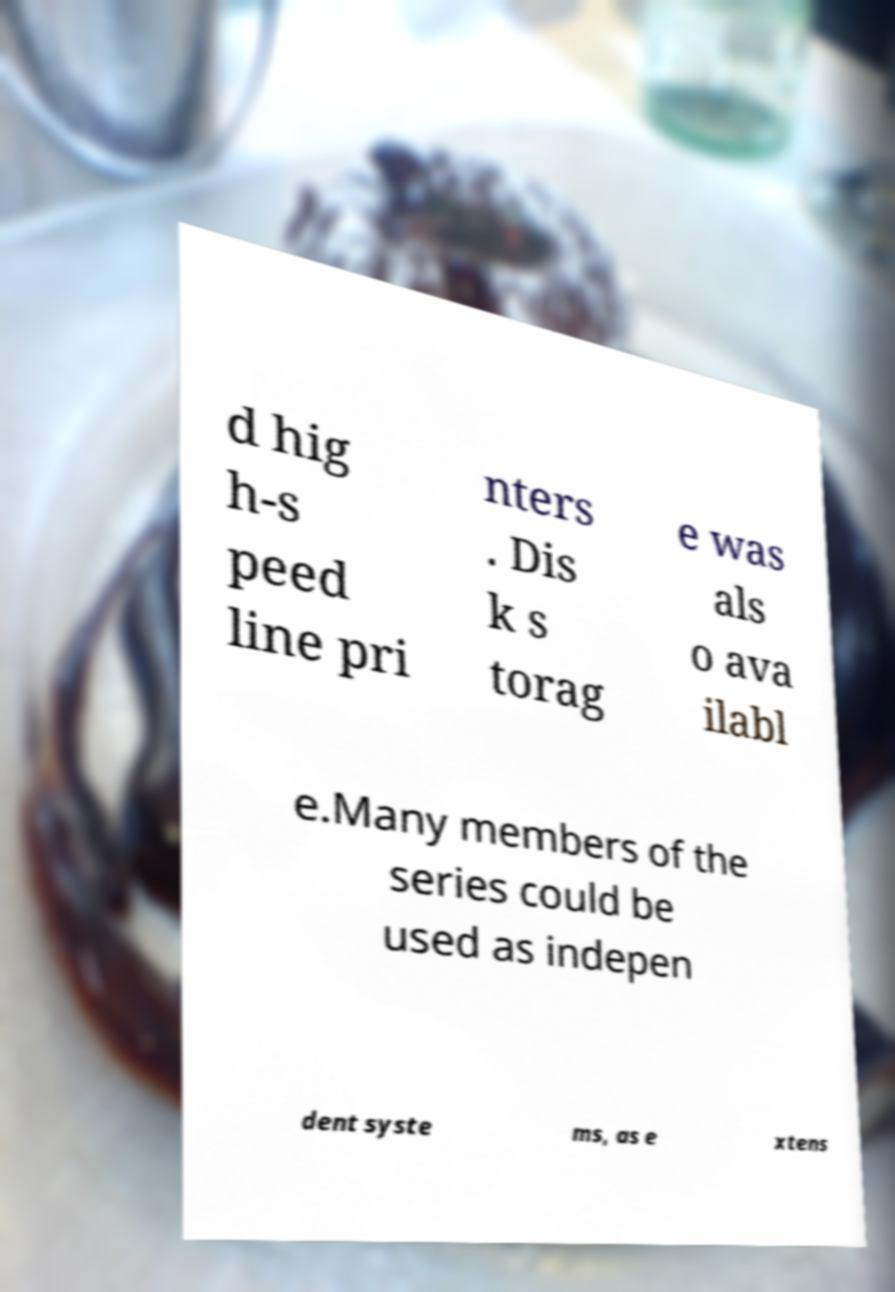Can you read and provide the text displayed in the image?This photo seems to have some interesting text. Can you extract and type it out for me? d hig h-s peed line pri nters . Dis k s torag e was als o ava ilabl e.Many members of the series could be used as indepen dent syste ms, as e xtens 